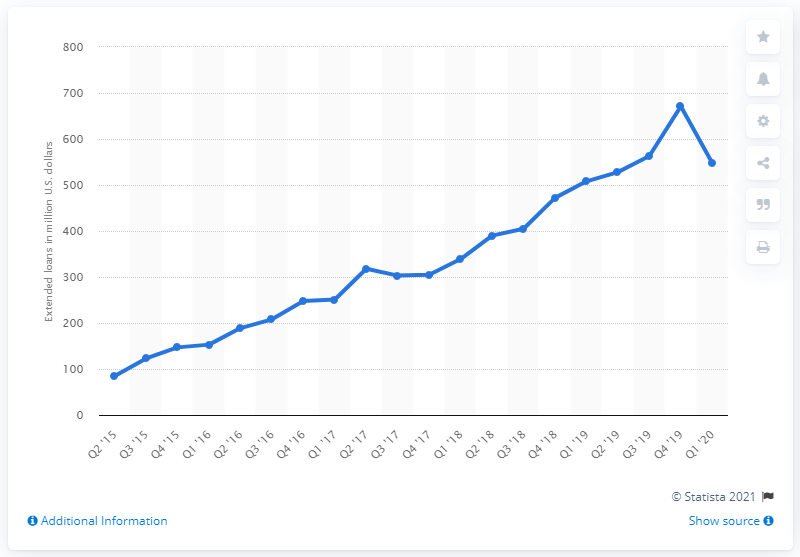Indicate a few pertinent items in this graphic. In the last quarter, the total amount of Square Capital's business loans was $548. 